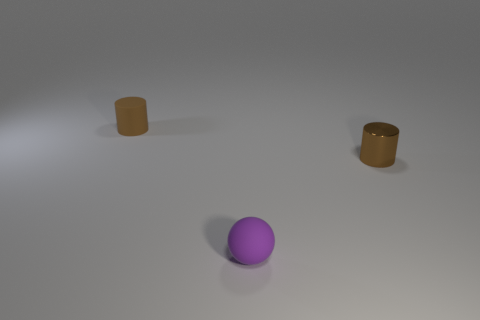What materials are the objects in the image made of? The objects in the image appear to be 3D renderings with different materials. The cylindrical objects seem to have a reflective, possibly metallic surface, suggesting they could be made of a polished metal. The round object in the center has a dull, non-reflective surface, hinting that it might represent a matte material like plastic or rubber. 